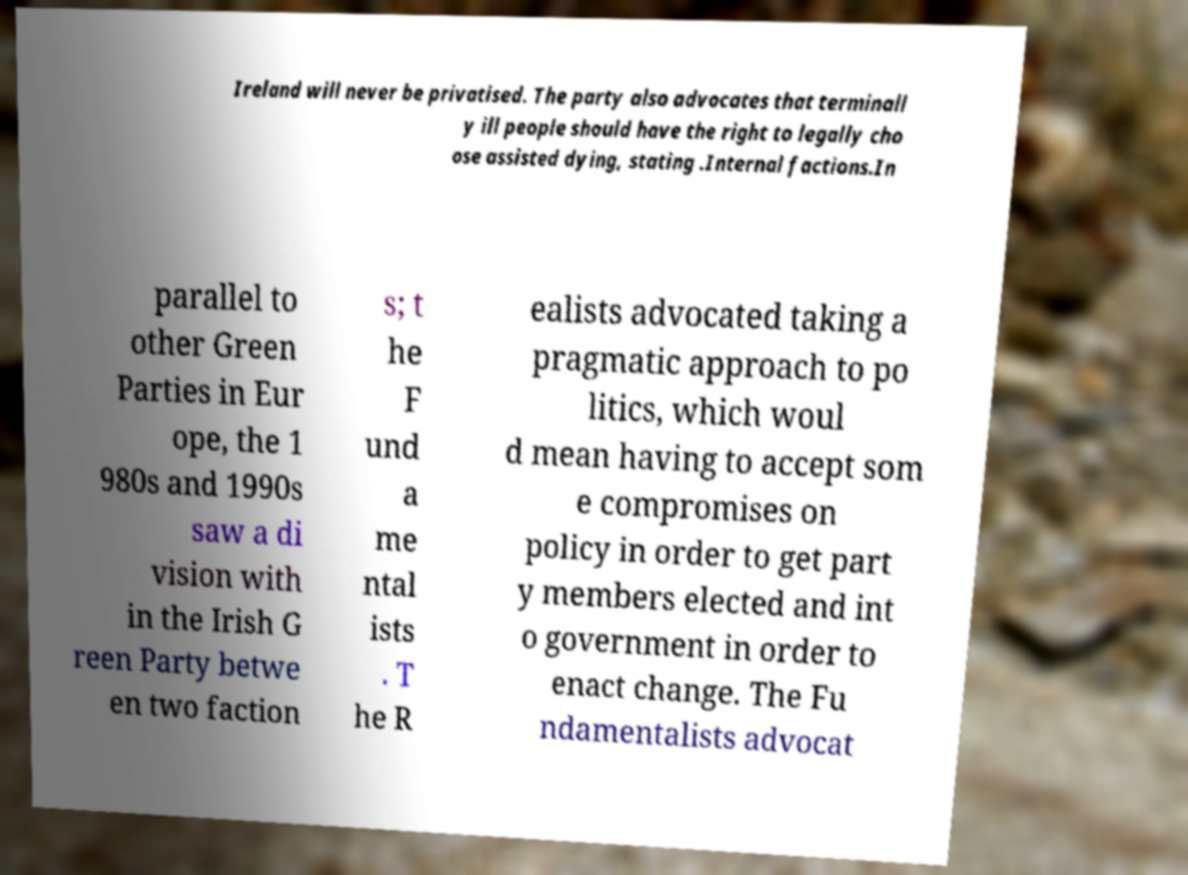Please identify and transcribe the text found in this image. Ireland will never be privatised. The party also advocates that terminall y ill people should have the right to legally cho ose assisted dying, stating .Internal factions.In parallel to other Green Parties in Eur ope, the 1 980s and 1990s saw a di vision with in the Irish G reen Party betwe en two faction s; t he F und a me ntal ists . T he R ealists advocated taking a pragmatic approach to po litics, which woul d mean having to accept som e compromises on policy in order to get part y members elected and int o government in order to enact change. The Fu ndamentalists advocat 